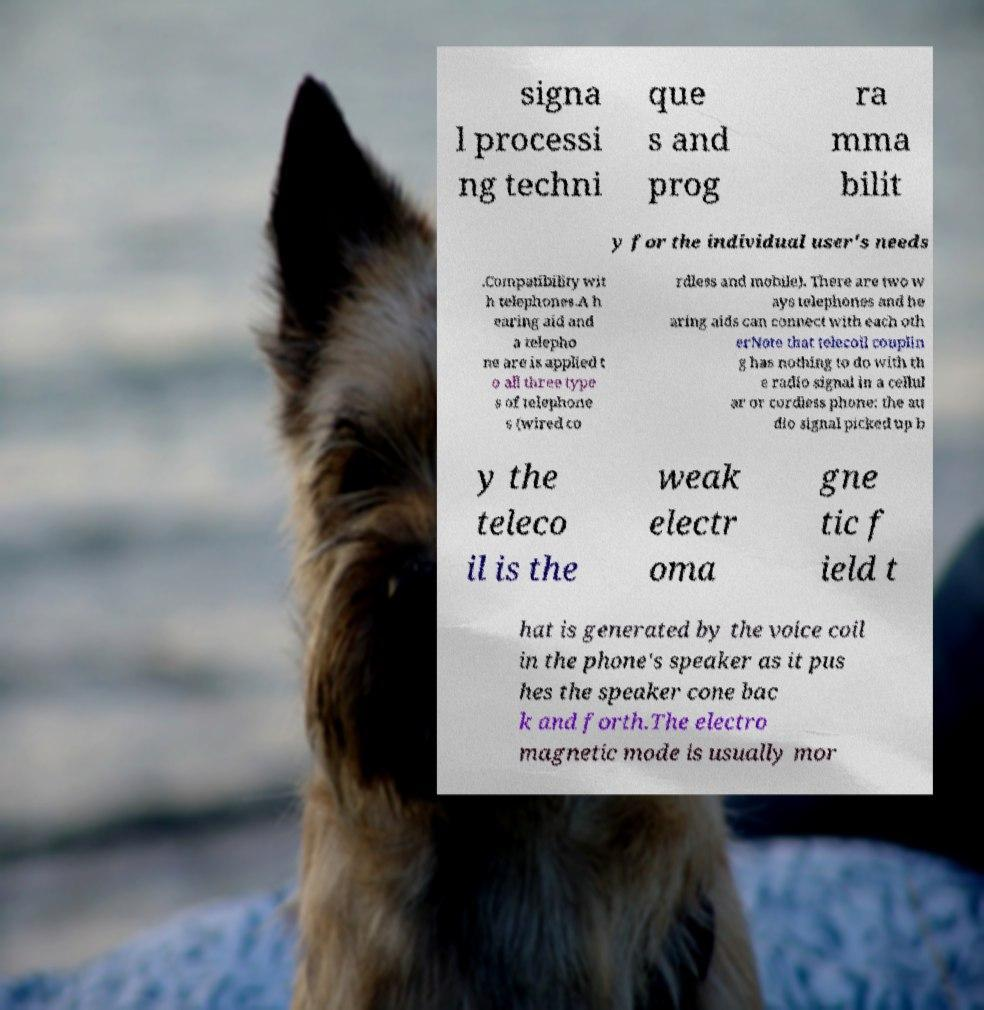There's text embedded in this image that I need extracted. Can you transcribe it verbatim? signa l processi ng techni que s and prog ra mma bilit y for the individual user's needs .Compatibility wit h telephones.A h earing aid and a telepho ne are is applied t o all three type s of telephone s (wired co rdless and mobile). There are two w ays telephones and he aring aids can connect with each oth erNote that telecoil couplin g has nothing to do with th e radio signal in a cellul ar or cordless phone: the au dio signal picked up b y the teleco il is the weak electr oma gne tic f ield t hat is generated by the voice coil in the phone's speaker as it pus hes the speaker cone bac k and forth.The electro magnetic mode is usually mor 